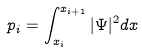<formula> <loc_0><loc_0><loc_500><loc_500>p _ { i } = \int _ { x _ { i } } ^ { x _ { i + 1 } } | \Psi | ^ { 2 } d x</formula> 